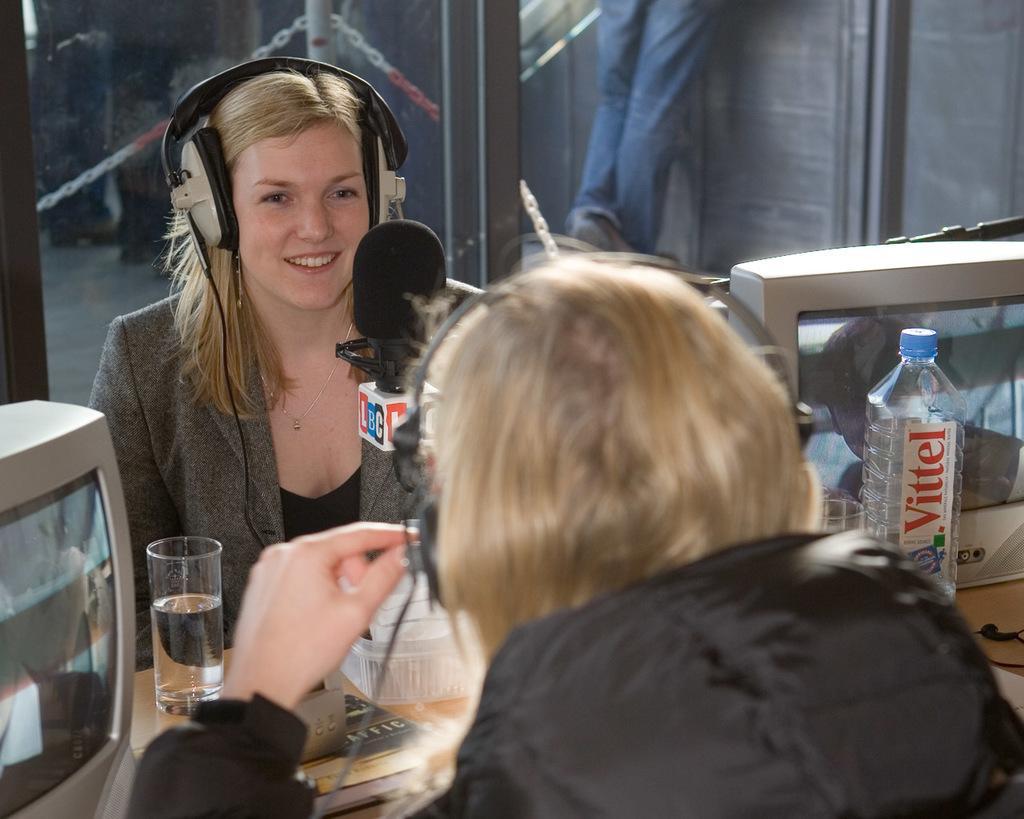Can you describe this image briefly? In the image we can see there are two people who are sitting and there is a mic in between them and a girl is wearing headphones. 